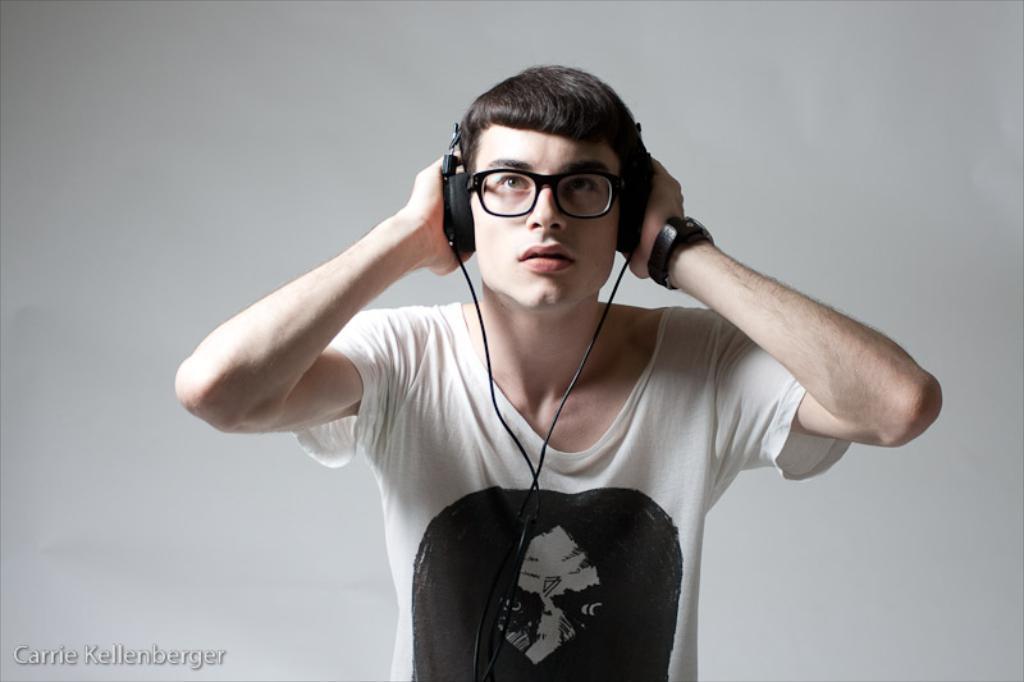How would you summarize this image in a sentence or two? This image consists of a man. He is wearing white T-shirt. He is wearing headphones and watch. 